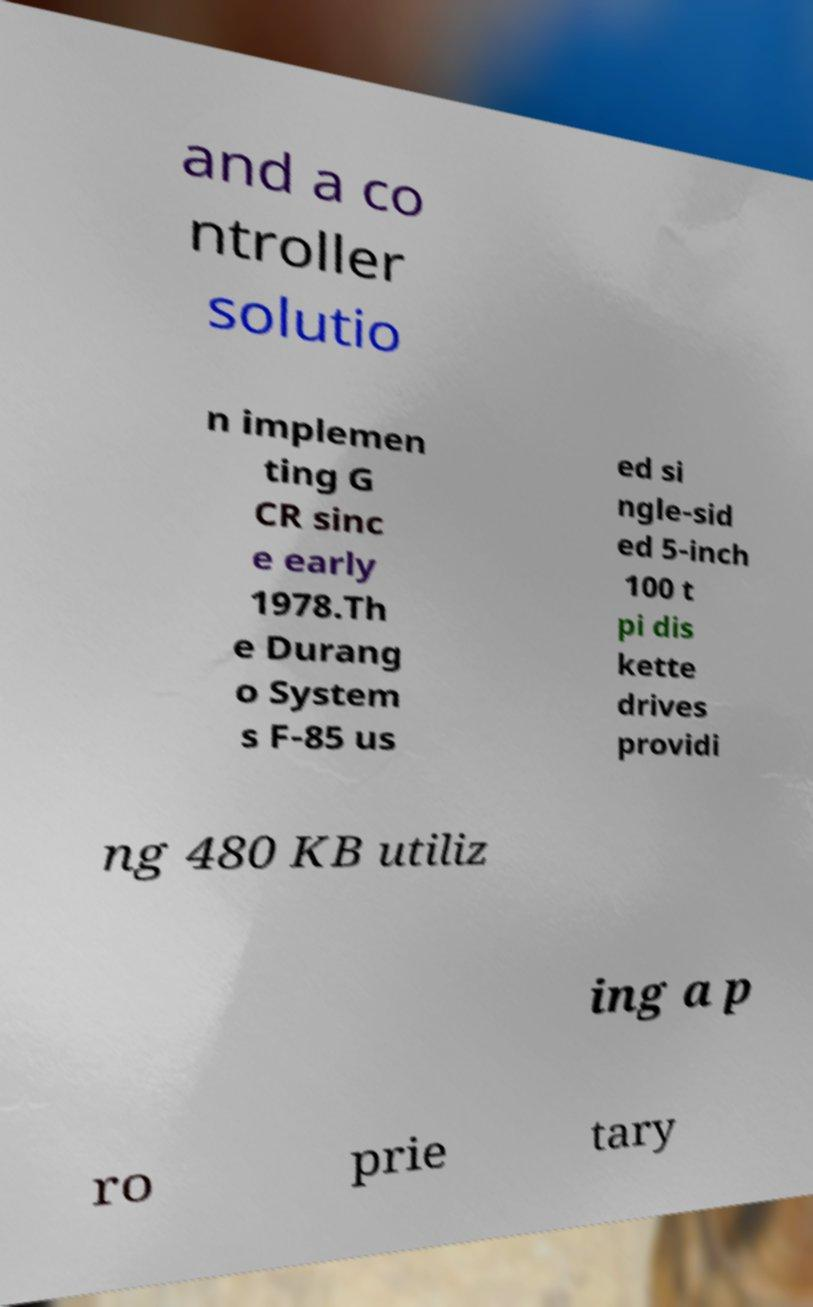Can you read and provide the text displayed in the image?This photo seems to have some interesting text. Can you extract and type it out for me? and a co ntroller solutio n implemen ting G CR sinc e early 1978.Th e Durang o System s F-85 us ed si ngle-sid ed 5-inch 100 t pi dis kette drives providi ng 480 KB utiliz ing a p ro prie tary 